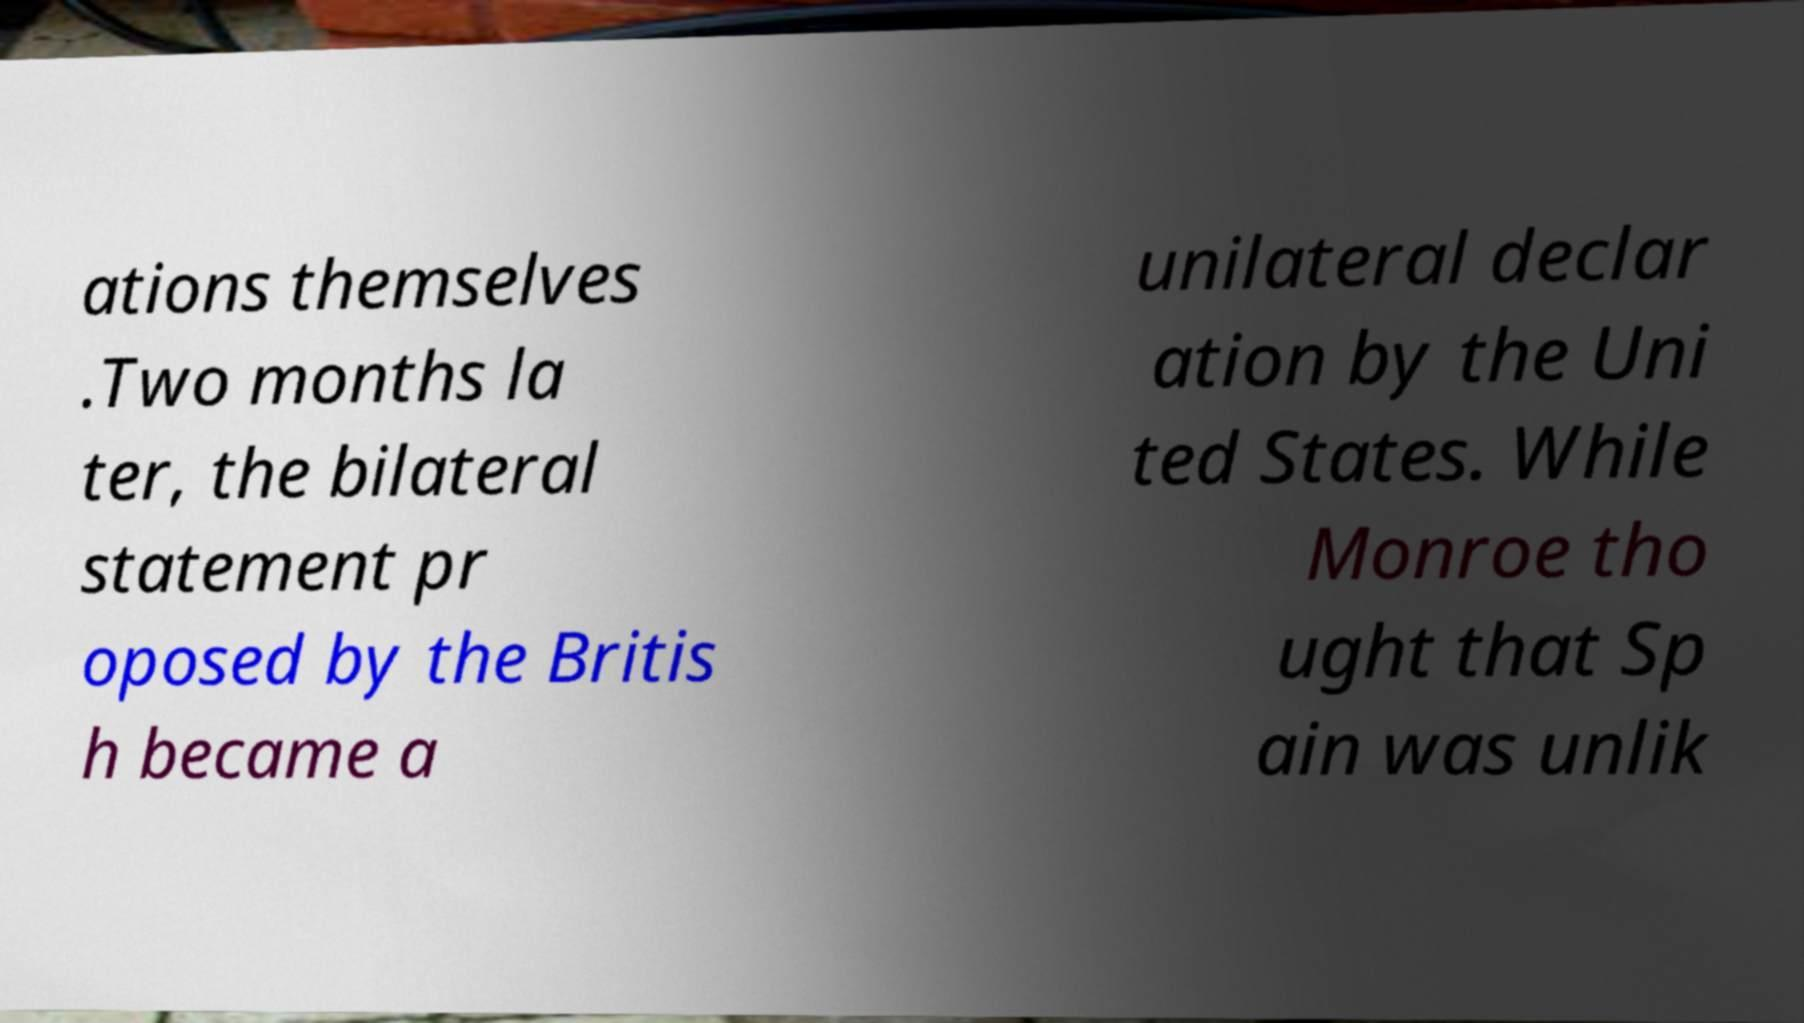Can you read and provide the text displayed in the image?This photo seems to have some interesting text. Can you extract and type it out for me? ations themselves .Two months la ter, the bilateral statement pr oposed by the Britis h became a unilateral declar ation by the Uni ted States. While Monroe tho ught that Sp ain was unlik 